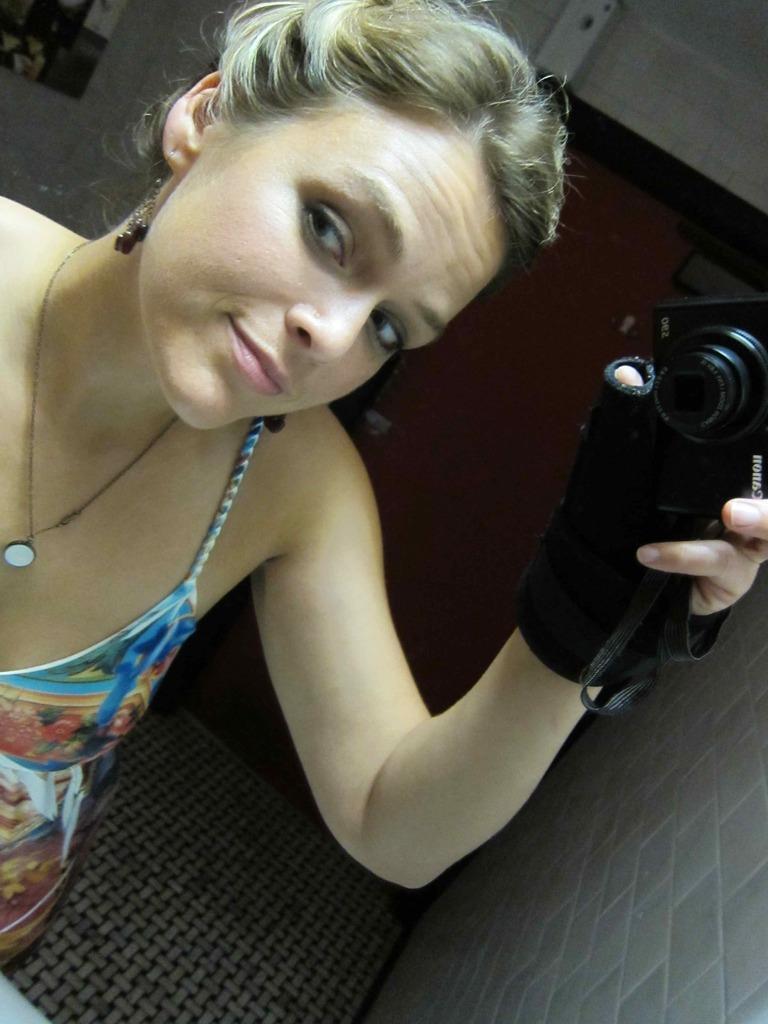In one or two sentences, can you explain what this image depicts? a person is holding a camera in her hand, wearing a black glove. at the right there is a wall. she is wearing a blue and white dress. 